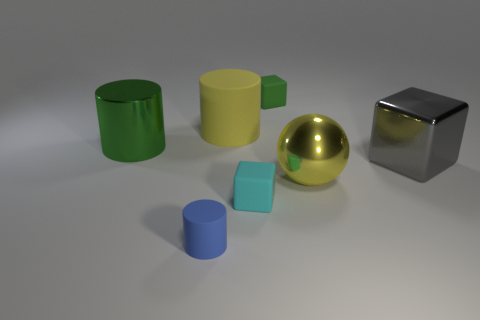There is a block to the left of the green rubber object; what number of tiny matte objects are on the left side of it?
Ensure brevity in your answer.  1. Are there any matte cylinders that have the same color as the sphere?
Your answer should be compact. Yes. Is the size of the gray cube the same as the green rubber block?
Your answer should be compact. No. Is the color of the shiny sphere the same as the large matte object?
Keep it short and to the point. Yes. What material is the green thing that is in front of the yellow object that is to the left of the green cube?
Your answer should be very brief. Metal. What is the material of the green thing that is the same shape as the blue rubber thing?
Offer a very short reply. Metal. There is a matte cylinder behind the green metal cylinder; is its size the same as the big green cylinder?
Your response must be concise. Yes. How many rubber things are either blue objects or tiny red things?
Offer a terse response. 1. There is a big thing that is to the right of the small cyan cube and left of the large gray metallic cube; what material is it made of?
Provide a short and direct response. Metal. Are the gray thing and the small cyan block made of the same material?
Provide a short and direct response. No. 